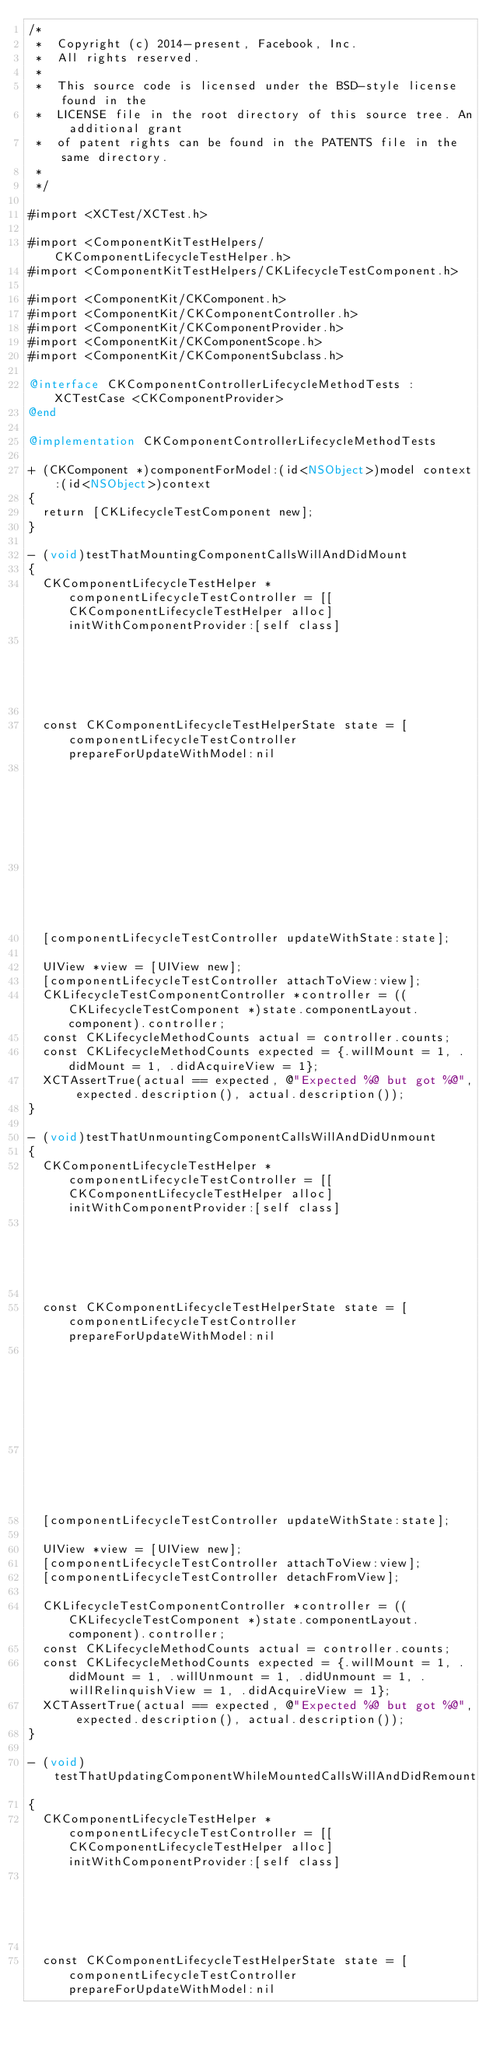Convert code to text. <code><loc_0><loc_0><loc_500><loc_500><_ObjectiveC_>/*
 *  Copyright (c) 2014-present, Facebook, Inc.
 *  All rights reserved.
 *
 *  This source code is licensed under the BSD-style license found in the
 *  LICENSE file in the root directory of this source tree. An additional grant
 *  of patent rights can be found in the PATENTS file in the same directory.
 *
 */

#import <XCTest/XCTest.h>

#import <ComponentKitTestHelpers/CKComponentLifecycleTestHelper.h>
#import <ComponentKitTestHelpers/CKLifecycleTestComponent.h>

#import <ComponentKit/CKComponent.h>
#import <ComponentKit/CKComponentController.h>
#import <ComponentKit/CKComponentProvider.h>
#import <ComponentKit/CKComponentScope.h>
#import <ComponentKit/CKComponentSubclass.h>

@interface CKComponentControllerLifecycleMethodTests : XCTestCase <CKComponentProvider>
@end

@implementation CKComponentControllerLifecycleMethodTests

+ (CKComponent *)componentForModel:(id<NSObject>)model context:(id<NSObject>)context
{
  return [CKLifecycleTestComponent new];
}

- (void)testThatMountingComponentCallsWillAndDidMount
{
  CKComponentLifecycleTestHelper *componentLifecycleTestController = [[CKComponentLifecycleTestHelper alloc] initWithComponentProvider:[self class]
                                                                                                                             sizeRangeProvider:nil];

  const CKComponentLifecycleTestHelperState state = [componentLifecycleTestController prepareForUpdateWithModel:nil
                                                                                                    constrainedSize:{{0,0}, {100, 100}}
                                                                                                            context:nil];
  [componentLifecycleTestController updateWithState:state];

  UIView *view = [UIView new];
  [componentLifecycleTestController attachToView:view];
  CKLifecycleTestComponentController *controller = ((CKLifecycleTestComponent *)state.componentLayout.component).controller;
  const CKLifecycleMethodCounts actual = controller.counts;
  const CKLifecycleMethodCounts expected = {.willMount = 1, .didMount = 1, .didAcquireView = 1};
  XCTAssertTrue(actual == expected, @"Expected %@ but got %@", expected.description(), actual.description());
}

- (void)testThatUnmountingComponentCallsWillAndDidUnmount
{
  CKComponentLifecycleTestHelper *componentLifecycleTestController = [[CKComponentLifecycleTestHelper alloc] initWithComponentProvider:[self class]
                                                                                                                             sizeRangeProvider:nil];

  const CKComponentLifecycleTestHelperState state = [componentLifecycleTestController prepareForUpdateWithModel:nil
                                                                                                    constrainedSize:{{0,0}, {100, 100}}
                                                                                                            context:nil];
  [componentLifecycleTestController updateWithState:state];

  UIView *view = [UIView new];
  [componentLifecycleTestController attachToView:view];
  [componentLifecycleTestController detachFromView];

  CKLifecycleTestComponentController *controller = ((CKLifecycleTestComponent *)state.componentLayout.component).controller;
  const CKLifecycleMethodCounts actual = controller.counts;
  const CKLifecycleMethodCounts expected = {.willMount = 1, .didMount = 1, .willUnmount = 1, .didUnmount = 1, .willRelinquishView = 1, .didAcquireView = 1};
  XCTAssertTrue(actual == expected, @"Expected %@ but got %@", expected.description(), actual.description());
}

- (void)testThatUpdatingComponentWhileMountedCallsWillAndDidRemount
{
  CKComponentLifecycleTestHelper *componentLifecycleTestController = [[CKComponentLifecycleTestHelper alloc] initWithComponentProvider:[self class]
                                                                                                                             sizeRangeProvider:nil];

  const CKComponentLifecycleTestHelperState state = [componentLifecycleTestController prepareForUpdateWithModel:nil</code> 